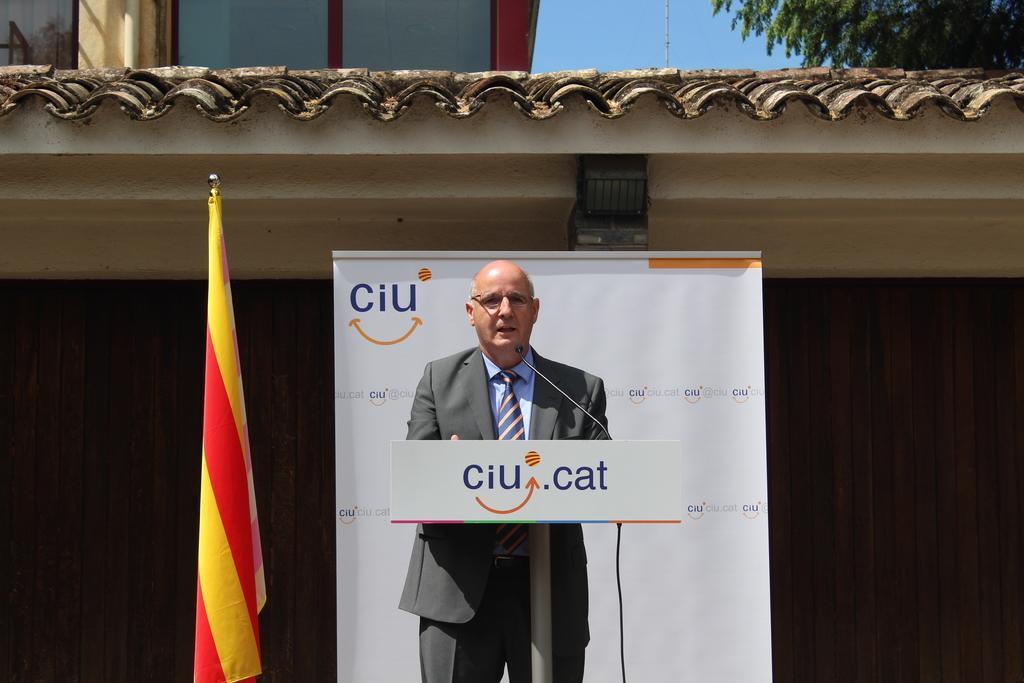Describe this image in one or two sentences. In the image a person is standing and speaking into a microphone. There is a flag, a building in the image. There is a tree at the top most right side of the image. 